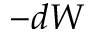Convert formula to latex. <formula><loc_0><loc_0><loc_500><loc_500>- d W</formula> 